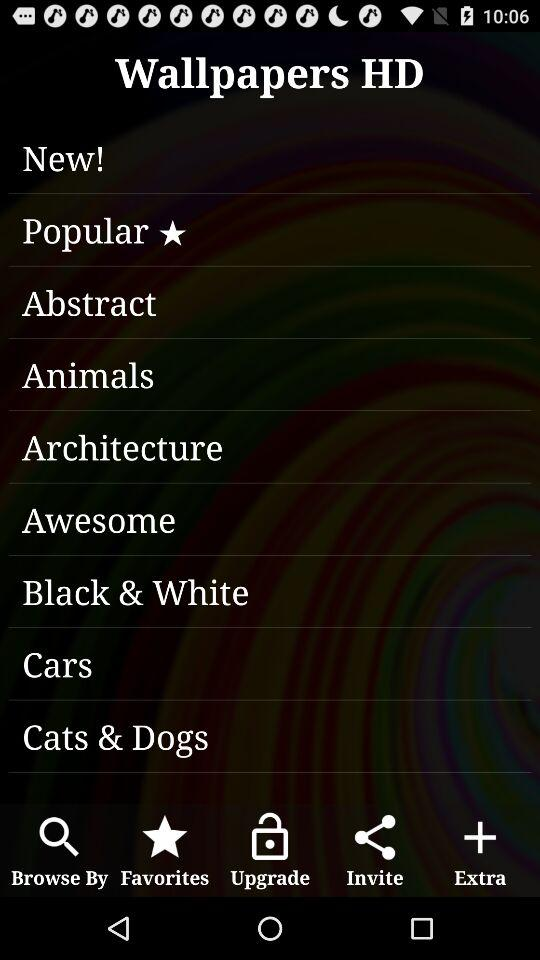Which applications are available for inviting?
When the provided information is insufficient, respond with <no answer>. <no answer> 